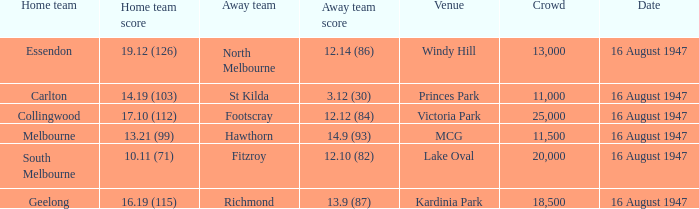What was the total size of the crowd when the away team scored 12.10 (82)? 20000.0. 